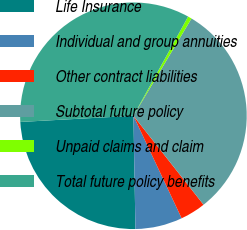Convert chart. <chart><loc_0><loc_0><loc_500><loc_500><pie_chart><fcel>Life Insurance<fcel>Individual and group annuities<fcel>Other contract liabilities<fcel>Subtotal future policy<fcel>Unpaid claims and claim<fcel>Total future policy benefits<nl><fcel>24.41%<fcel>6.71%<fcel>3.63%<fcel>30.8%<fcel>0.55%<fcel>33.88%<nl></chart> 